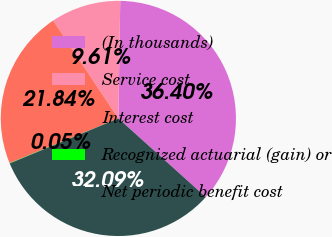Convert chart. <chart><loc_0><loc_0><loc_500><loc_500><pie_chart><fcel>(In thousands)<fcel>Service cost<fcel>Interest cost<fcel>Recognized actuarial (gain) or<fcel>Net periodic benefit cost<nl><fcel>36.4%<fcel>9.61%<fcel>21.84%<fcel>0.05%<fcel>32.09%<nl></chart> 